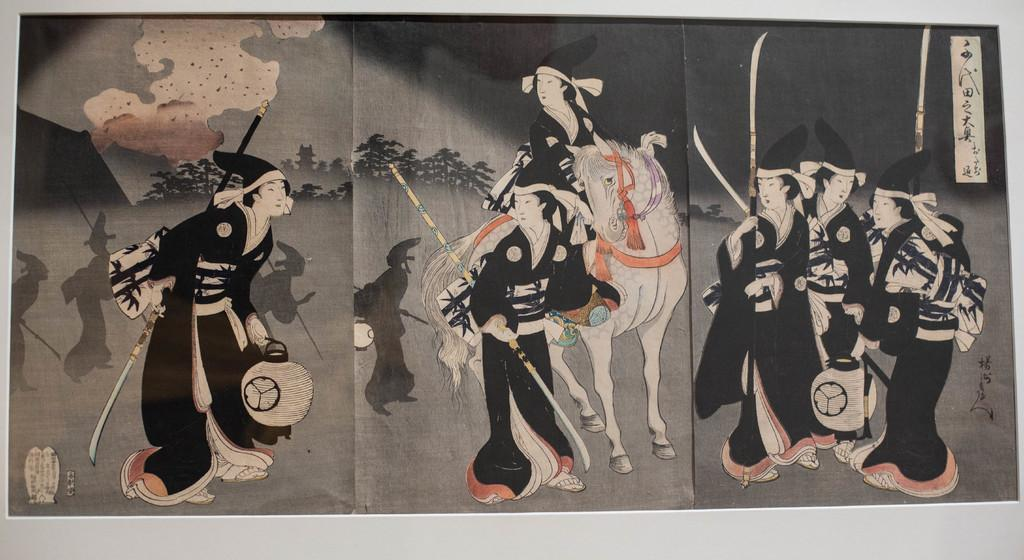What type of artwork is depicted in the image? The image is a painting. What subjects are present in the painting? There are people and a horse in the image. What type of natural environment is shown in the painting? There are trees in the image, suggesting a natural setting. What is visible in the background of the painting? The sky is visible in the image. Is there any text present in the painting? Yes, there is text in the image. Where is the toothbrush located in the painting? There is no toothbrush present in the painting. What trick is being performed by the people in the painting? There is no trick being performed by the people in the painting; they are simply depicted as subjects in the artwork. 